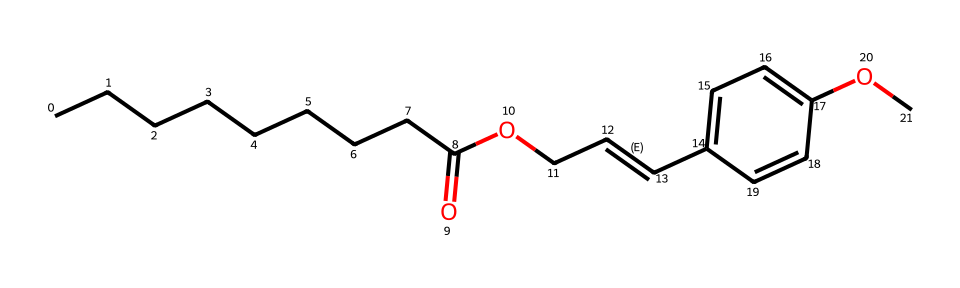What is the molecular formula of octyl methoxycinnamate? By interpreting the SMILES representation, count the number of each type of atom: there are 16 carbon atoms, 24 hydrogen atoms, and 4 oxygen atoms, giving the formula C16H24O4.
Answer: C16H24O4 How many carbon atoms are present in octyl methoxycinnamate? From the SMILES notation, count the "C" symbols, resulting in a total of 16 carbon atoms in the structure.
Answer: 16 What type of functional groups are present in octyl methoxycinnamate? Analyzing the structure shows the presence of ester and phenol functional groups, as indicated by the carbonyl (C=O) and aromatic (C=C with OH) sections of the chemical.
Answer: ester and phenol Which part of the molecule is responsible for its UV-filtering ability? The aromatic ring structure is key in absorbing UV light because it has delocalized pi electrons that can interact with UV radiation, making it effective as a UV filter.
Answer: aromatic ring What is the role of the methoxy group in octyl methoxycinnamate? The methoxy group (-OCH3) enhances the solubility and stability of the compound, allowing for better incorporation into sunscreen formulations.
Answer: enhances solubility and stability What is the hybridization of the carbon atoms in the aromatic ring of octyl methoxycinnamate? In the aromatic ring, carbon atoms are sp2 hybridized due to the presence of double bonds and the planar structure of the ring, which allows for delocalization of electrons.
Answer: sp2 What is the total number of double bonds in octyl methoxycinnamate? By examining the SMILES structure, there are two double bonds present: one in the alkene chain and one in the aromatic ring, totaling to two double bonds in the molecule.
Answer: 2 